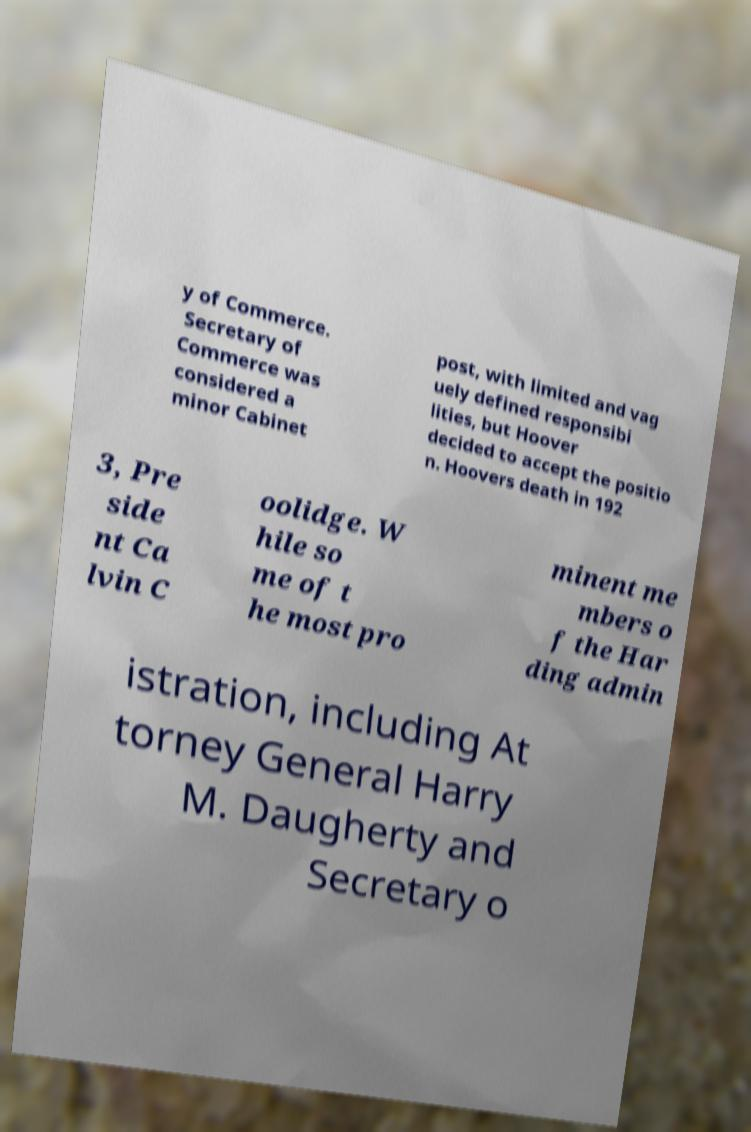Could you assist in decoding the text presented in this image and type it out clearly? y of Commerce. Secretary of Commerce was considered a minor Cabinet post, with limited and vag uely defined responsibi lities, but Hoover decided to accept the positio n. Hoovers death in 192 3, Pre side nt Ca lvin C oolidge. W hile so me of t he most pro minent me mbers o f the Har ding admin istration, including At torney General Harry M. Daugherty and Secretary o 